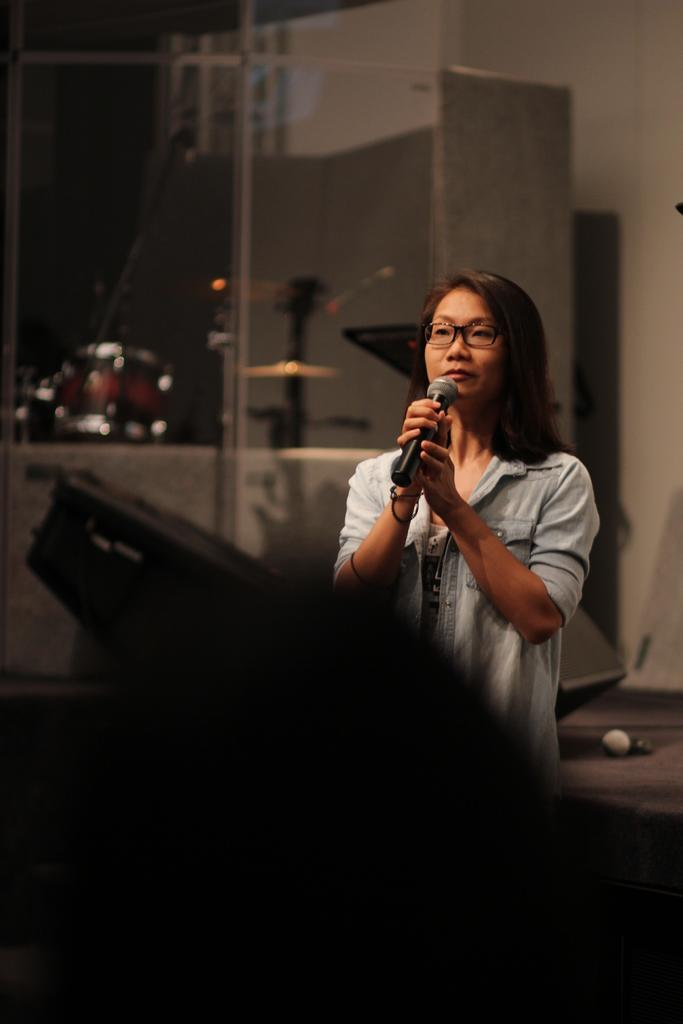Who is the main subject in the image? There is a woman in the image. What is the woman holding in her hands? The woman is holding a microphone in her hands. Can you describe the woman's appearance? The woman is wearing spectacles. How would you describe the background of the image? The background of the image is blurred. What type of advertisement is being displayed on the stage in the image? There is no stage or advertisement present in the image; it features a woman holding a microphone with a blurred background. 